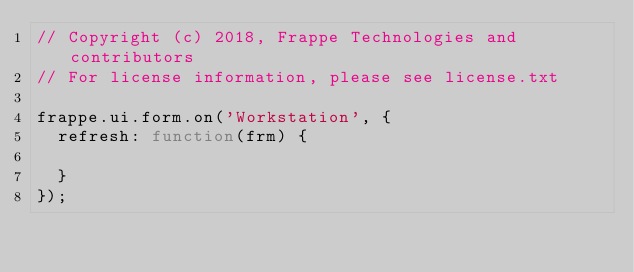Convert code to text. <code><loc_0><loc_0><loc_500><loc_500><_JavaScript_>// Copyright (c) 2018, Frappe Technologies and contributors
// For license information, please see license.txt

frappe.ui.form.on('Workstation', {
	refresh: function(frm) {

	}
});
</code> 